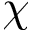Convert formula to latex. <formula><loc_0><loc_0><loc_500><loc_500>\chi</formula> 